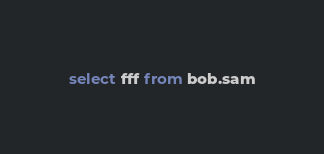<code> <loc_0><loc_0><loc_500><loc_500><_SQL_>select fff from bob.sam

</code> 